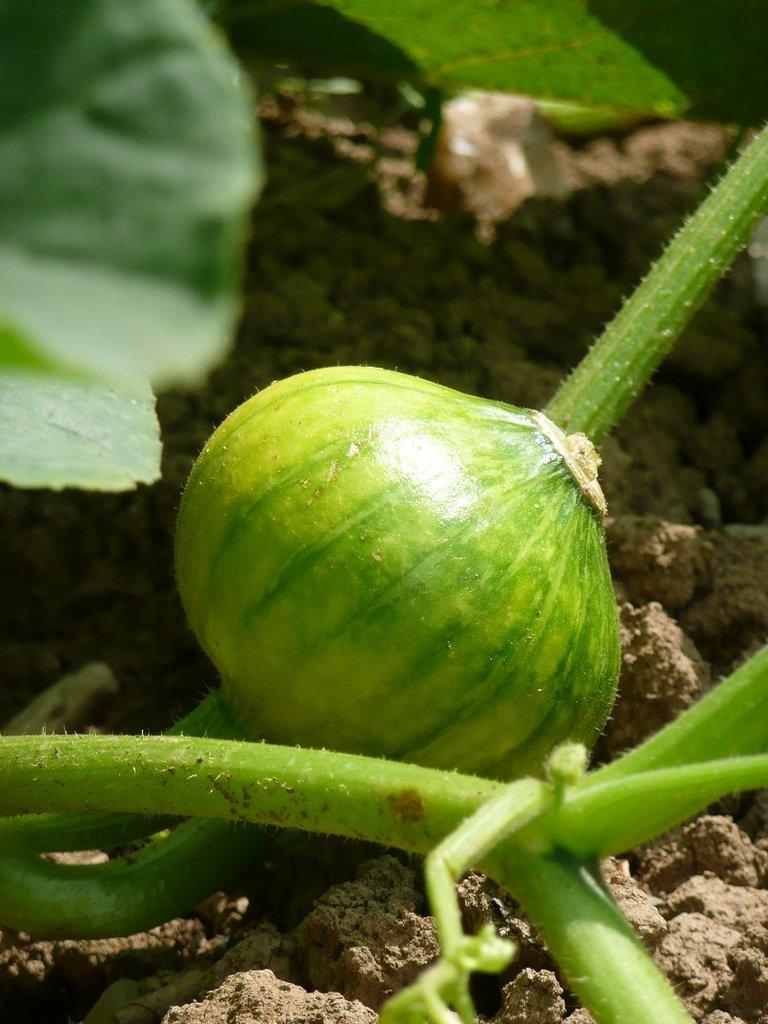What type of food item is present in the image? There is a vegetable in the image. What is the color of the vegetable? The vegetable is green in color. Does the vegetable have any specific features? Yes, the vegetable has a stem. What can be seen at the bottom of the image? There is mud visible at the bottom of the image. How many leaves are visible at the top of the image? There are two leaves visible at the top of the image. What type of scarecrow is standing next to the vegetable in the image? There is no scarecrow present in the image; it only features a vegetable with a stem, mud, and leaves. What historical event is depicted in the image? The image does not depict any historical event; it is a simple image of a vegetable with its features and surroundings. 